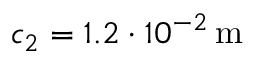Convert formula to latex. <formula><loc_0><loc_0><loc_500><loc_500>c _ { 2 } = 1 . 2 \cdot 1 0 ^ { - 2 } \, m</formula> 